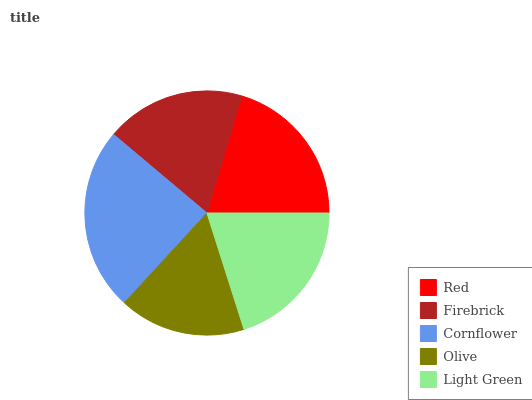Is Olive the minimum?
Answer yes or no. Yes. Is Cornflower the maximum?
Answer yes or no. Yes. Is Firebrick the minimum?
Answer yes or no. No. Is Firebrick the maximum?
Answer yes or no. No. Is Red greater than Firebrick?
Answer yes or no. Yes. Is Firebrick less than Red?
Answer yes or no. Yes. Is Firebrick greater than Red?
Answer yes or no. No. Is Red less than Firebrick?
Answer yes or no. No. Is Light Green the high median?
Answer yes or no. Yes. Is Light Green the low median?
Answer yes or no. Yes. Is Olive the high median?
Answer yes or no. No. Is Cornflower the low median?
Answer yes or no. No. 